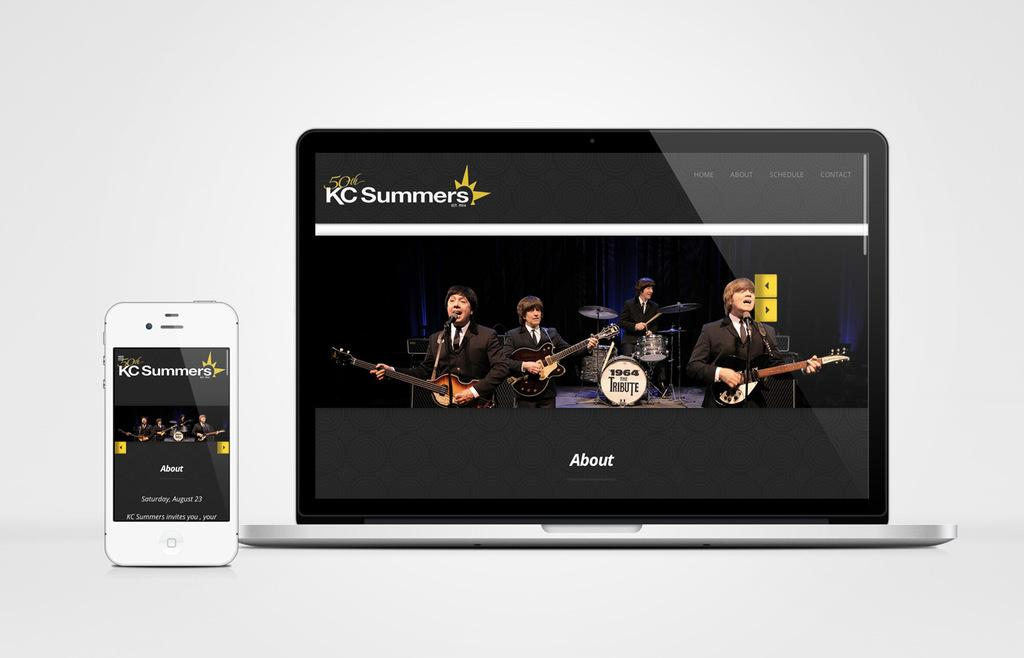<image>
Share a concise interpretation of the image provided. A phone and a laptop are both showing the KC Summers webpage. 